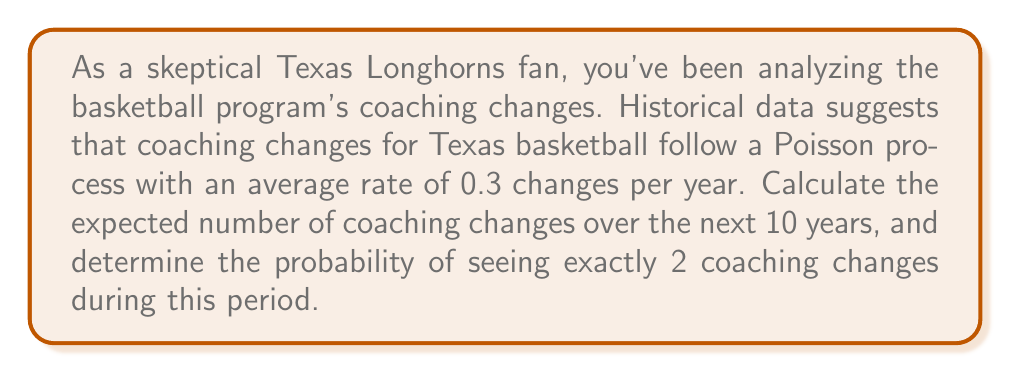Solve this math problem. Let's approach this problem step-by-step:

1) For a Poisson process with rate $\lambda$ per unit time, the expected number of events in time $t$ is given by $\lambda t$.

2) Given:
   - Rate ($\lambda$) = 0.3 changes per year
   - Time period ($t$) = 10 years

3) Expected number of coaching changes in 10 years:
   $$E[X] = \lambda t = 0.3 \times 10 = 3$$

4) To find the probability of exactly 2 coaching changes in 10 years, we use the Poisson probability mass function:

   $$P(X = k) = \frac{e^{-\lambda t}(\lambda t)^k}{k!}$$

   Where:
   - $k$ is the number of events (2 in this case)
   - $\lambda t$ is the expected number of events (3 as calculated above)

5) Plugging in the values:

   $$P(X = 2) = \frac{e^{-3}(3)^2}{2!}$$

6) Calculating:
   $$P(X = 2) = \frac{e^{-3} \times 9}{2} \approx 0.2240$$

7) Therefore, the probability of exactly 2 coaching changes in 10 years is approximately 0.2240 or 22.40%.
Answer: Expected number of changes: 3; Probability of exactly 2 changes: 0.2240 